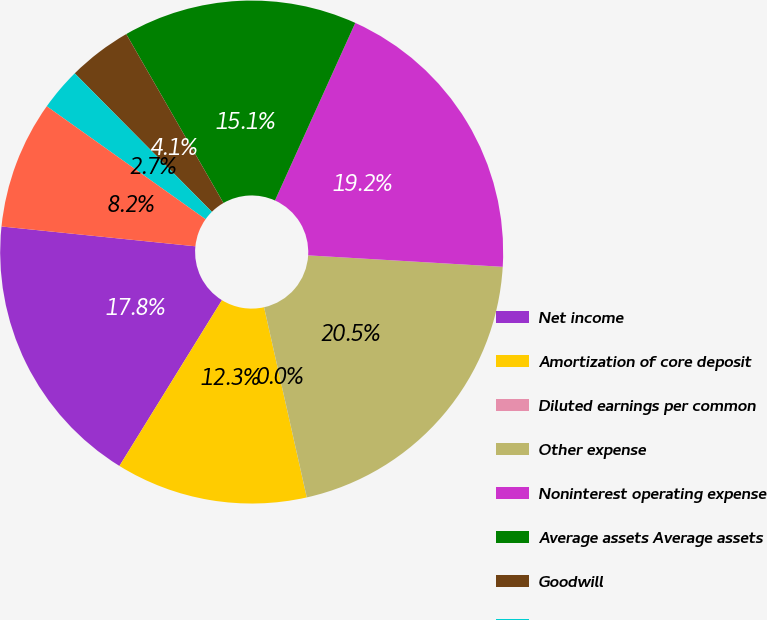<chart> <loc_0><loc_0><loc_500><loc_500><pie_chart><fcel>Net income<fcel>Amortization of core deposit<fcel>Diluted earnings per common<fcel>Other expense<fcel>Noninterest operating expense<fcel>Average assets Average assets<fcel>Goodwill<fcel>Core deposit and other<fcel>Average total equity<nl><fcel>17.81%<fcel>12.33%<fcel>0.0%<fcel>20.55%<fcel>19.18%<fcel>15.07%<fcel>4.11%<fcel>2.74%<fcel>8.22%<nl></chart> 